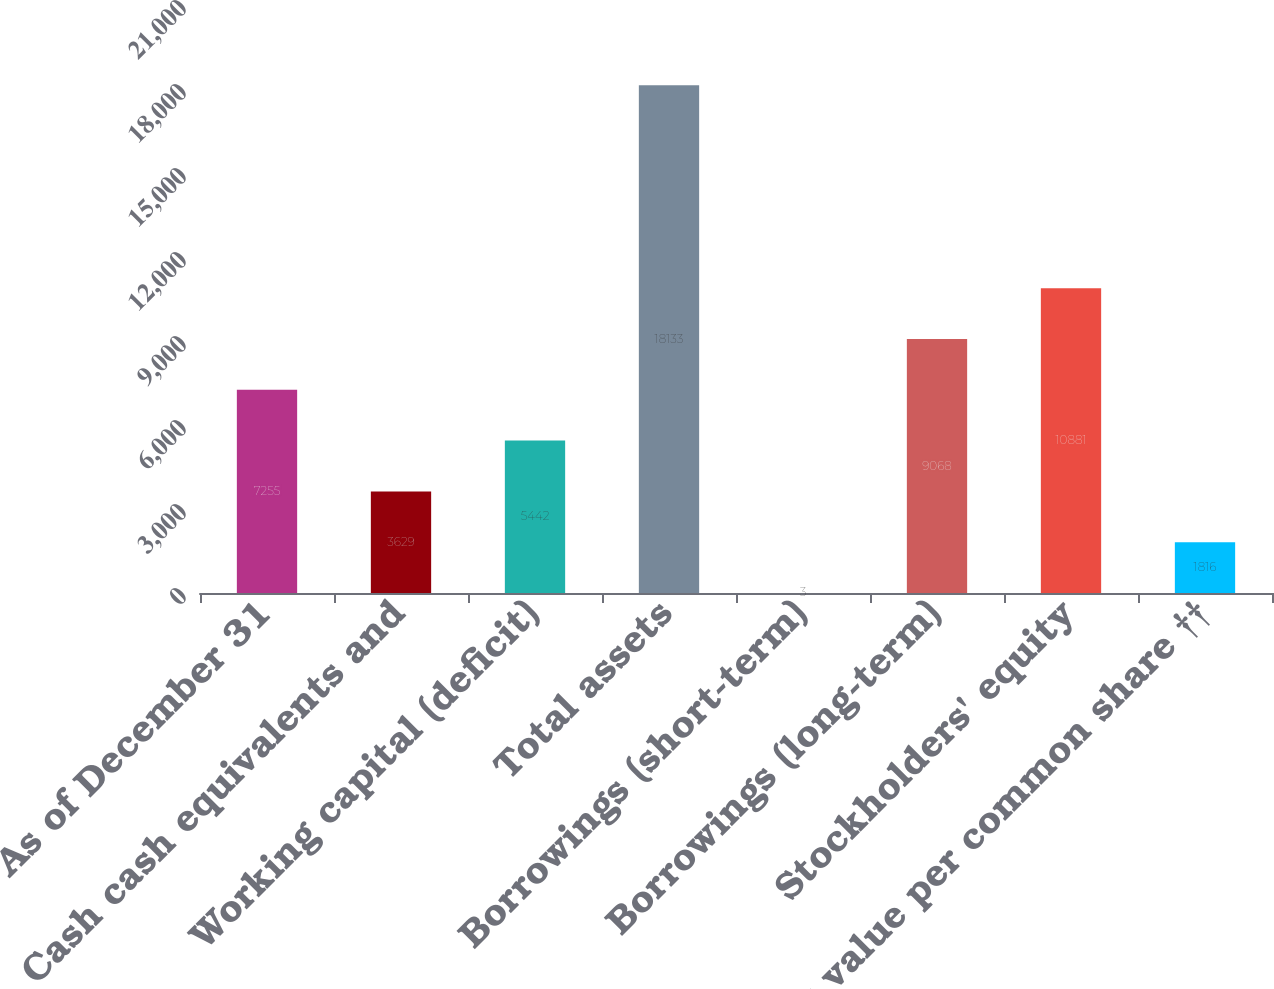Convert chart. <chart><loc_0><loc_0><loc_500><loc_500><bar_chart><fcel>As of December 31<fcel>Cash cash equivalents and<fcel>Working capital (deficit)<fcel>Total assets<fcel>Borrowings (short-term)<fcel>Borrowings (long-term)<fcel>Stockholders' equity<fcel>Book value per common share ††<nl><fcel>7255<fcel>3629<fcel>5442<fcel>18133<fcel>3<fcel>9068<fcel>10881<fcel>1816<nl></chart> 